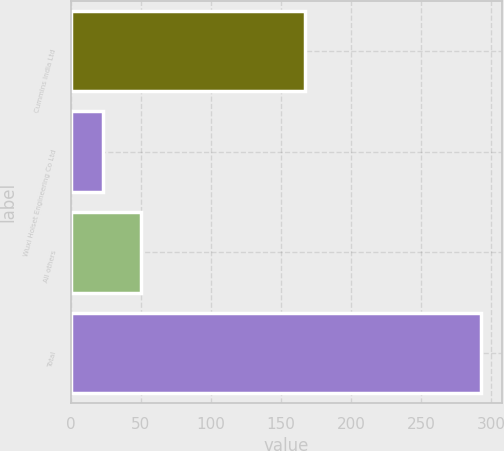Convert chart. <chart><loc_0><loc_0><loc_500><loc_500><bar_chart><fcel>Cummins India Ltd<fcel>Wuxi Holset Engineering Co Ltd<fcel>All others<fcel>Total<nl><fcel>167<fcel>23<fcel>50<fcel>293<nl></chart> 